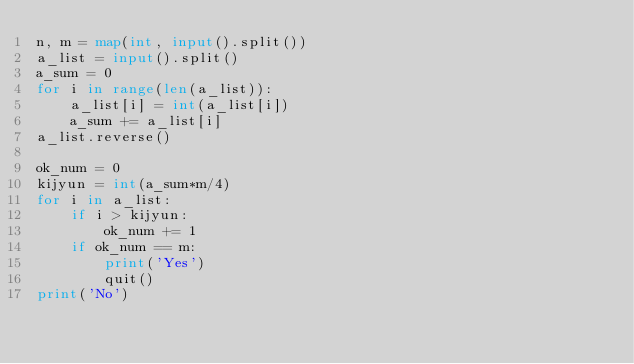<code> <loc_0><loc_0><loc_500><loc_500><_Python_>n, m = map(int, input().split())
a_list = input().split()
a_sum = 0
for i in range(len(a_list)):
    a_list[i] = int(a_list[i])
    a_sum += a_list[i]
a_list.reverse()

ok_num = 0
kijyun = int(a_sum*m/4)
for i in a_list:
    if i > kijyun:
        ok_num += 1
    if ok_num == m:
        print('Yes')
        quit()
print('No')

</code> 